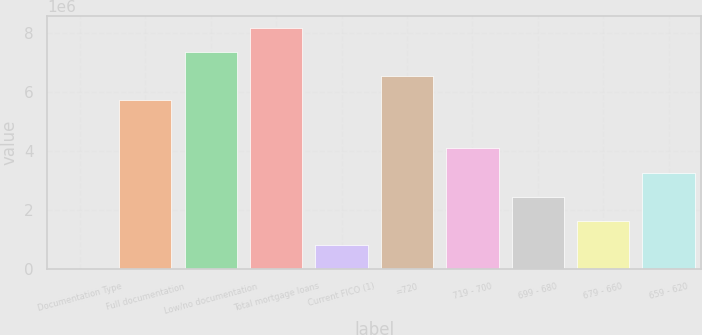Convert chart to OTSL. <chart><loc_0><loc_0><loc_500><loc_500><bar_chart><fcel>Documentation Type<fcel>Full documentation<fcel>Low/no documentation<fcel>Total mortgage loans<fcel>Current FICO (1)<fcel>=720<fcel>719 - 700<fcel>699 - 680<fcel>679 - 660<fcel>659 - 620<nl><fcel>2010<fcel>5.71983e+06<fcel>7.3535e+06<fcel>8.17033e+06<fcel>818842<fcel>6.53667e+06<fcel>4.08617e+06<fcel>2.45251e+06<fcel>1.63567e+06<fcel>3.26934e+06<nl></chart> 